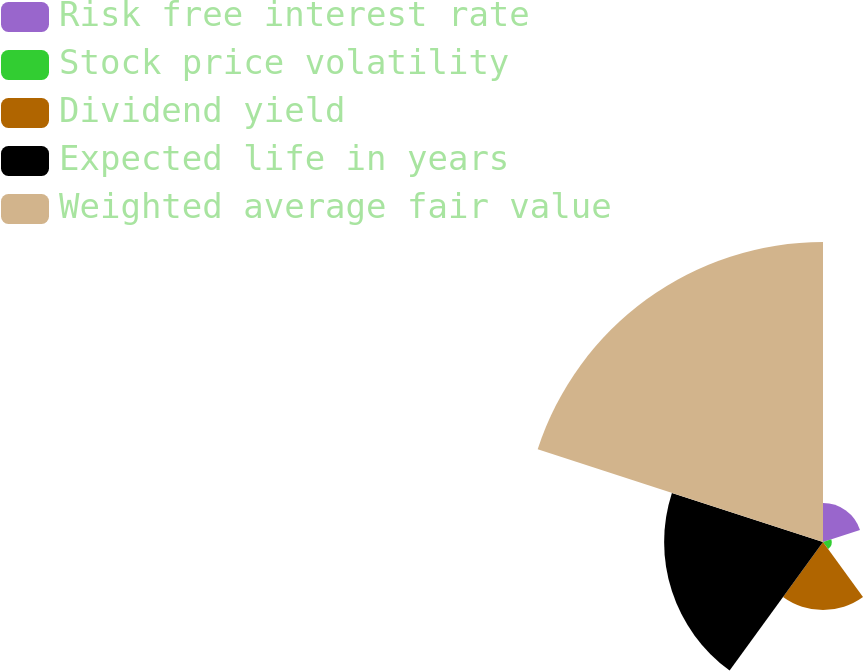Convert chart to OTSL. <chart><loc_0><loc_0><loc_500><loc_500><pie_chart><fcel>Risk free interest rate<fcel>Stock price volatility<fcel>Dividend yield<fcel>Expected life in years<fcel>Weighted average fair value<nl><fcel>6.77%<fcel>1.52%<fcel>11.84%<fcel>27.65%<fcel>52.21%<nl></chart> 